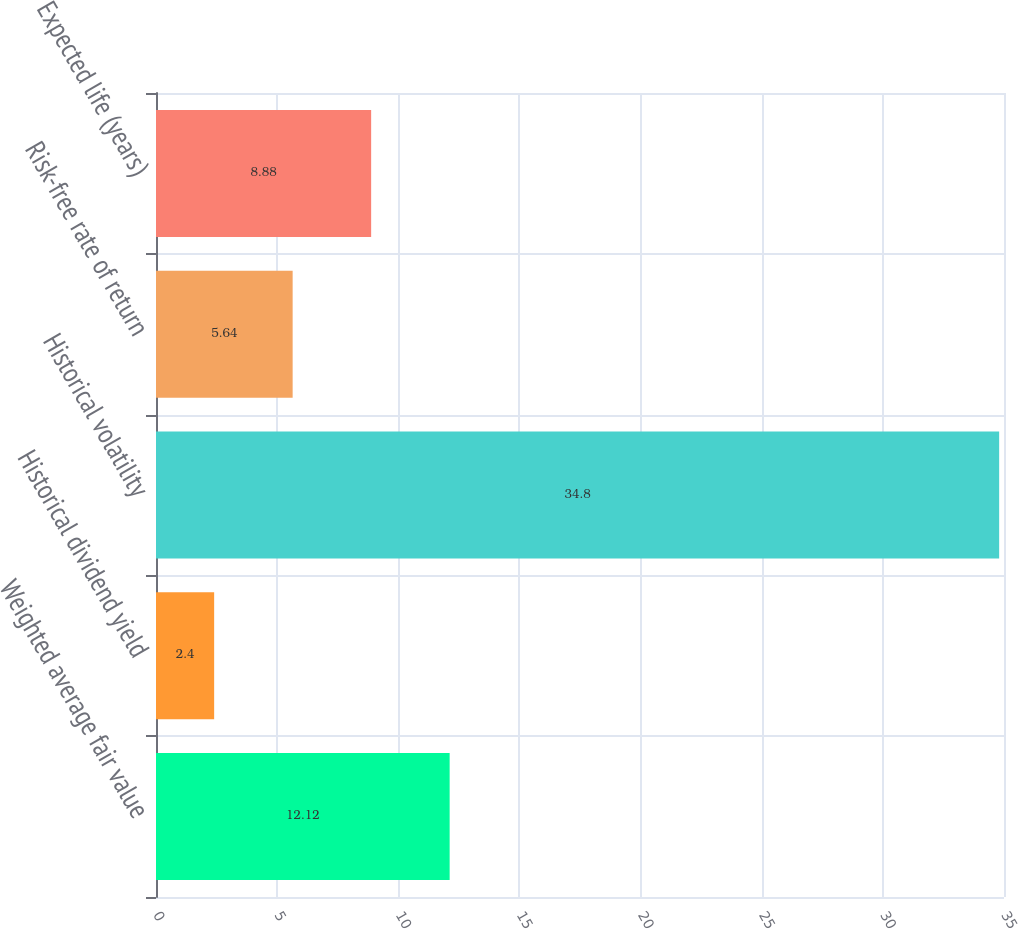Convert chart. <chart><loc_0><loc_0><loc_500><loc_500><bar_chart><fcel>Weighted average fair value<fcel>Historical dividend yield<fcel>Historical volatility<fcel>Risk-free rate of return<fcel>Expected life (years)<nl><fcel>12.12<fcel>2.4<fcel>34.8<fcel>5.64<fcel>8.88<nl></chart> 